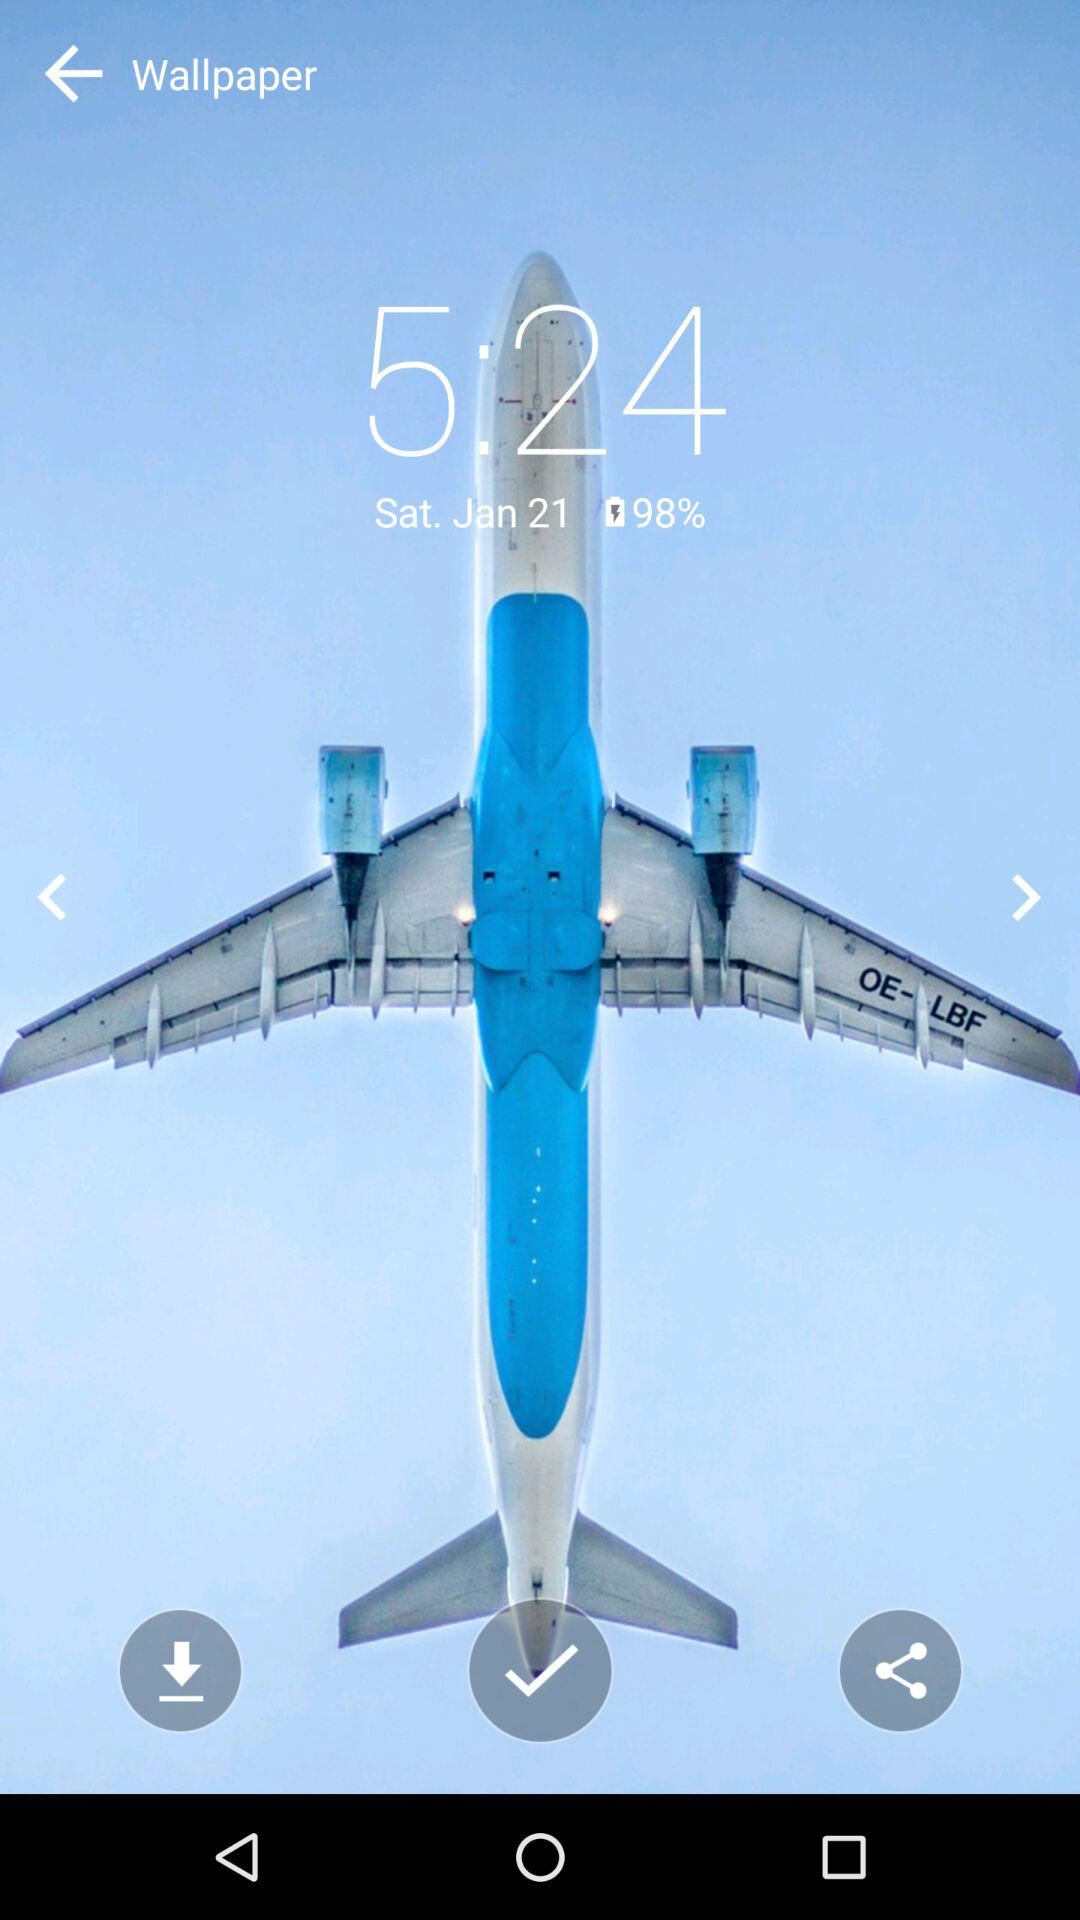What is the charging percentage? The charging percentage is 98. 